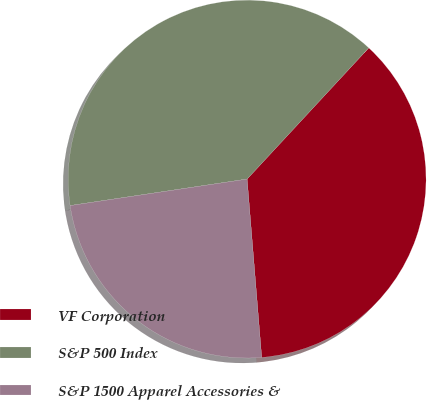<chart> <loc_0><loc_0><loc_500><loc_500><pie_chart><fcel>VF Corporation<fcel>S&P 500 Index<fcel>S&P 1500 Apparel Accessories &<nl><fcel>36.8%<fcel>39.26%<fcel>23.93%<nl></chart> 